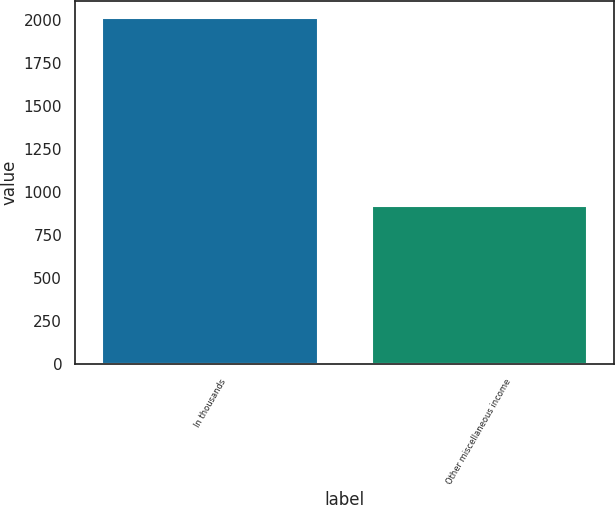Convert chart. <chart><loc_0><loc_0><loc_500><loc_500><bar_chart><fcel>In thousands<fcel>Other miscellaneous income<nl><fcel>2010<fcel>918<nl></chart> 